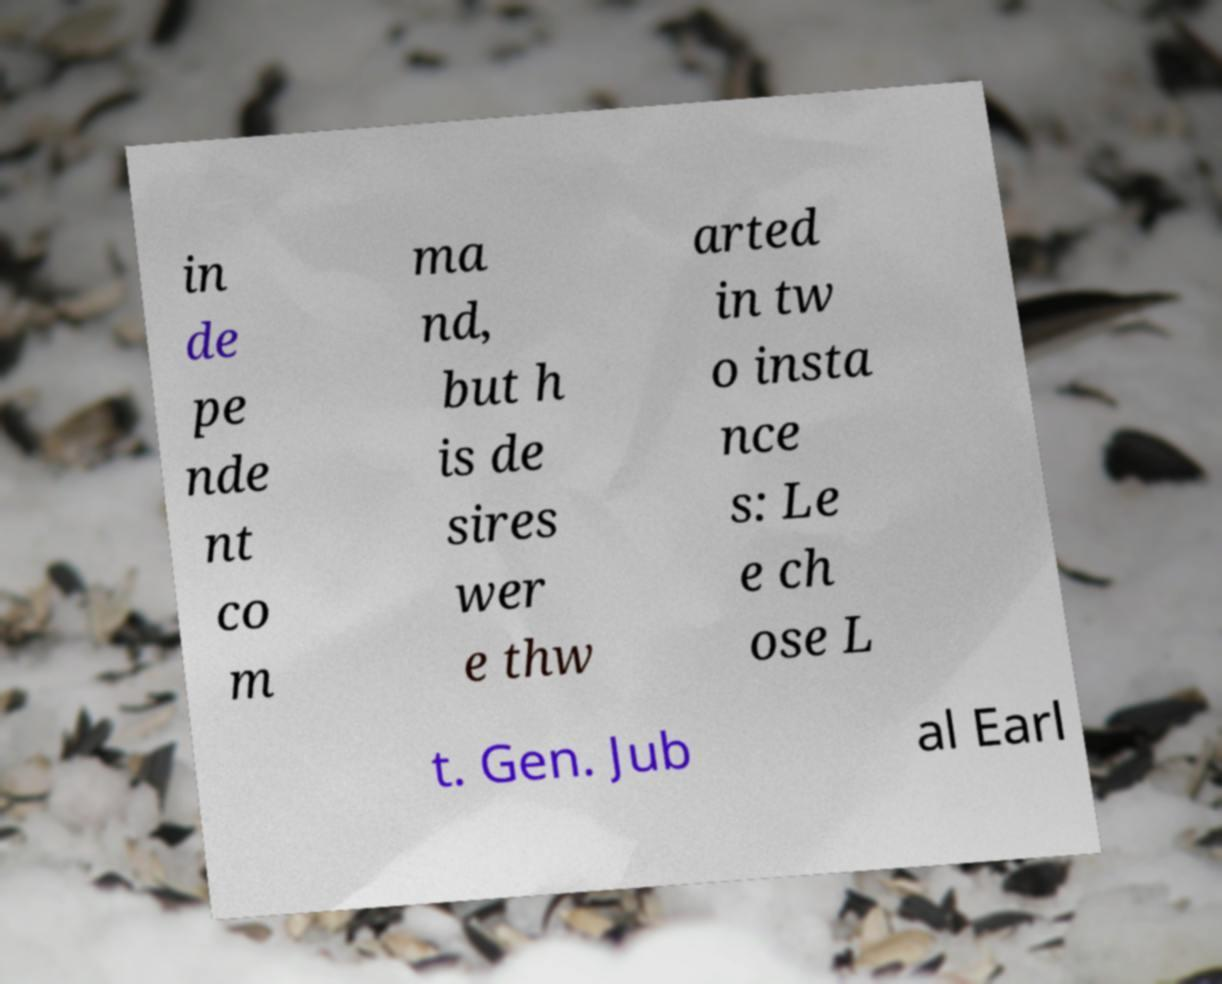Please identify and transcribe the text found in this image. in de pe nde nt co m ma nd, but h is de sires wer e thw arted in tw o insta nce s: Le e ch ose L t. Gen. Jub al Earl 